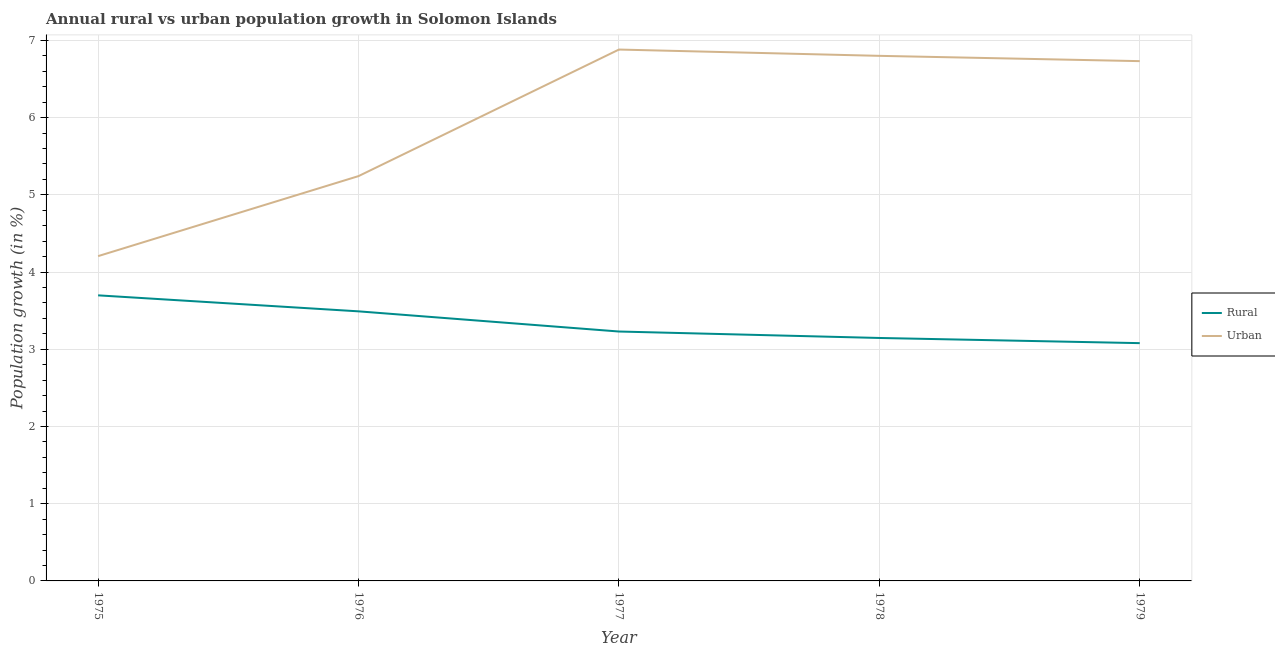How many different coloured lines are there?
Ensure brevity in your answer.  2. What is the urban population growth in 1977?
Offer a very short reply. 6.88. Across all years, what is the maximum rural population growth?
Your response must be concise. 3.7. Across all years, what is the minimum urban population growth?
Your response must be concise. 4.21. In which year was the rural population growth minimum?
Provide a short and direct response. 1979. What is the total urban population growth in the graph?
Provide a short and direct response. 29.86. What is the difference between the rural population growth in 1976 and that in 1977?
Provide a succinct answer. 0.26. What is the difference between the rural population growth in 1979 and the urban population growth in 1975?
Provide a succinct answer. -1.13. What is the average urban population growth per year?
Provide a succinct answer. 5.97. In the year 1979, what is the difference between the urban population growth and rural population growth?
Keep it short and to the point. 3.65. What is the ratio of the urban population growth in 1975 to that in 1979?
Ensure brevity in your answer.  0.62. Is the difference between the urban population growth in 1975 and 1977 greater than the difference between the rural population growth in 1975 and 1977?
Give a very brief answer. No. What is the difference between the highest and the second highest urban population growth?
Provide a short and direct response. 0.08. What is the difference between the highest and the lowest urban population growth?
Provide a short and direct response. 2.67. Is the sum of the rural population growth in 1976 and 1978 greater than the maximum urban population growth across all years?
Keep it short and to the point. No. Does the urban population growth monotonically increase over the years?
Provide a succinct answer. No. How many years are there in the graph?
Make the answer very short. 5. What is the difference between two consecutive major ticks on the Y-axis?
Provide a short and direct response. 1. Where does the legend appear in the graph?
Ensure brevity in your answer.  Center right. How are the legend labels stacked?
Ensure brevity in your answer.  Vertical. What is the title of the graph?
Offer a very short reply. Annual rural vs urban population growth in Solomon Islands. What is the label or title of the X-axis?
Give a very brief answer. Year. What is the label or title of the Y-axis?
Offer a very short reply. Population growth (in %). What is the Population growth (in %) of Rural in 1975?
Your response must be concise. 3.7. What is the Population growth (in %) in Urban  in 1975?
Offer a terse response. 4.21. What is the Population growth (in %) in Rural in 1976?
Your answer should be very brief. 3.49. What is the Population growth (in %) in Urban  in 1976?
Offer a very short reply. 5.24. What is the Population growth (in %) of Rural in 1977?
Make the answer very short. 3.23. What is the Population growth (in %) in Urban  in 1977?
Provide a short and direct response. 6.88. What is the Population growth (in %) in Rural in 1978?
Your answer should be very brief. 3.15. What is the Population growth (in %) in Urban  in 1978?
Provide a succinct answer. 6.8. What is the Population growth (in %) of Rural in 1979?
Make the answer very short. 3.08. What is the Population growth (in %) of Urban  in 1979?
Provide a short and direct response. 6.73. Across all years, what is the maximum Population growth (in %) of Rural?
Make the answer very short. 3.7. Across all years, what is the maximum Population growth (in %) in Urban ?
Provide a short and direct response. 6.88. Across all years, what is the minimum Population growth (in %) of Rural?
Make the answer very short. 3.08. Across all years, what is the minimum Population growth (in %) in Urban ?
Your answer should be compact. 4.21. What is the total Population growth (in %) of Rural in the graph?
Give a very brief answer. 16.64. What is the total Population growth (in %) in Urban  in the graph?
Make the answer very short. 29.86. What is the difference between the Population growth (in %) of Rural in 1975 and that in 1976?
Provide a short and direct response. 0.21. What is the difference between the Population growth (in %) in Urban  in 1975 and that in 1976?
Make the answer very short. -1.04. What is the difference between the Population growth (in %) of Rural in 1975 and that in 1977?
Keep it short and to the point. 0.47. What is the difference between the Population growth (in %) in Urban  in 1975 and that in 1977?
Offer a terse response. -2.67. What is the difference between the Population growth (in %) of Rural in 1975 and that in 1978?
Provide a succinct answer. 0.55. What is the difference between the Population growth (in %) of Urban  in 1975 and that in 1978?
Keep it short and to the point. -2.59. What is the difference between the Population growth (in %) in Rural in 1975 and that in 1979?
Your response must be concise. 0.62. What is the difference between the Population growth (in %) of Urban  in 1975 and that in 1979?
Your answer should be very brief. -2.52. What is the difference between the Population growth (in %) in Rural in 1976 and that in 1977?
Make the answer very short. 0.26. What is the difference between the Population growth (in %) of Urban  in 1976 and that in 1977?
Your answer should be compact. -1.64. What is the difference between the Population growth (in %) in Rural in 1976 and that in 1978?
Keep it short and to the point. 0.34. What is the difference between the Population growth (in %) of Urban  in 1976 and that in 1978?
Give a very brief answer. -1.56. What is the difference between the Population growth (in %) of Rural in 1976 and that in 1979?
Ensure brevity in your answer.  0.41. What is the difference between the Population growth (in %) in Urban  in 1976 and that in 1979?
Your answer should be compact. -1.49. What is the difference between the Population growth (in %) of Rural in 1977 and that in 1978?
Make the answer very short. 0.08. What is the difference between the Population growth (in %) in Urban  in 1977 and that in 1978?
Ensure brevity in your answer.  0.08. What is the difference between the Population growth (in %) of Rural in 1977 and that in 1979?
Offer a terse response. 0.15. What is the difference between the Population growth (in %) in Rural in 1978 and that in 1979?
Offer a terse response. 0.07. What is the difference between the Population growth (in %) in Urban  in 1978 and that in 1979?
Provide a succinct answer. 0.07. What is the difference between the Population growth (in %) in Rural in 1975 and the Population growth (in %) in Urban  in 1976?
Offer a terse response. -1.54. What is the difference between the Population growth (in %) in Rural in 1975 and the Population growth (in %) in Urban  in 1977?
Keep it short and to the point. -3.18. What is the difference between the Population growth (in %) in Rural in 1975 and the Population growth (in %) in Urban  in 1978?
Your answer should be compact. -3.1. What is the difference between the Population growth (in %) in Rural in 1975 and the Population growth (in %) in Urban  in 1979?
Offer a very short reply. -3.03. What is the difference between the Population growth (in %) in Rural in 1976 and the Population growth (in %) in Urban  in 1977?
Your answer should be very brief. -3.39. What is the difference between the Population growth (in %) of Rural in 1976 and the Population growth (in %) of Urban  in 1978?
Your answer should be very brief. -3.31. What is the difference between the Population growth (in %) in Rural in 1976 and the Population growth (in %) in Urban  in 1979?
Make the answer very short. -3.24. What is the difference between the Population growth (in %) in Rural in 1977 and the Population growth (in %) in Urban  in 1978?
Offer a very short reply. -3.57. What is the difference between the Population growth (in %) in Rural in 1977 and the Population growth (in %) in Urban  in 1979?
Keep it short and to the point. -3.5. What is the difference between the Population growth (in %) of Rural in 1978 and the Population growth (in %) of Urban  in 1979?
Provide a short and direct response. -3.58. What is the average Population growth (in %) of Rural per year?
Make the answer very short. 3.33. What is the average Population growth (in %) of Urban  per year?
Offer a very short reply. 5.97. In the year 1975, what is the difference between the Population growth (in %) in Rural and Population growth (in %) in Urban ?
Provide a short and direct response. -0.51. In the year 1976, what is the difference between the Population growth (in %) in Rural and Population growth (in %) in Urban ?
Your response must be concise. -1.75. In the year 1977, what is the difference between the Population growth (in %) of Rural and Population growth (in %) of Urban ?
Your answer should be very brief. -3.65. In the year 1978, what is the difference between the Population growth (in %) of Rural and Population growth (in %) of Urban ?
Your answer should be compact. -3.65. In the year 1979, what is the difference between the Population growth (in %) in Rural and Population growth (in %) in Urban ?
Offer a very short reply. -3.65. What is the ratio of the Population growth (in %) in Rural in 1975 to that in 1976?
Your answer should be very brief. 1.06. What is the ratio of the Population growth (in %) of Urban  in 1975 to that in 1976?
Your response must be concise. 0.8. What is the ratio of the Population growth (in %) in Rural in 1975 to that in 1977?
Provide a succinct answer. 1.15. What is the ratio of the Population growth (in %) in Urban  in 1975 to that in 1977?
Give a very brief answer. 0.61. What is the ratio of the Population growth (in %) of Rural in 1975 to that in 1978?
Provide a succinct answer. 1.18. What is the ratio of the Population growth (in %) of Urban  in 1975 to that in 1978?
Ensure brevity in your answer.  0.62. What is the ratio of the Population growth (in %) in Rural in 1975 to that in 1979?
Your response must be concise. 1.2. What is the ratio of the Population growth (in %) of Urban  in 1975 to that in 1979?
Provide a short and direct response. 0.62. What is the ratio of the Population growth (in %) in Rural in 1976 to that in 1977?
Your response must be concise. 1.08. What is the ratio of the Population growth (in %) of Urban  in 1976 to that in 1977?
Provide a succinct answer. 0.76. What is the ratio of the Population growth (in %) of Rural in 1976 to that in 1978?
Keep it short and to the point. 1.11. What is the ratio of the Population growth (in %) of Urban  in 1976 to that in 1978?
Give a very brief answer. 0.77. What is the ratio of the Population growth (in %) of Rural in 1976 to that in 1979?
Offer a terse response. 1.13. What is the ratio of the Population growth (in %) in Urban  in 1976 to that in 1979?
Provide a succinct answer. 0.78. What is the ratio of the Population growth (in %) in Rural in 1977 to that in 1978?
Give a very brief answer. 1.03. What is the ratio of the Population growth (in %) of Urban  in 1977 to that in 1978?
Make the answer very short. 1.01. What is the ratio of the Population growth (in %) of Rural in 1977 to that in 1979?
Your answer should be compact. 1.05. What is the ratio of the Population growth (in %) of Urban  in 1977 to that in 1979?
Your response must be concise. 1.02. What is the ratio of the Population growth (in %) in Rural in 1978 to that in 1979?
Keep it short and to the point. 1.02. What is the ratio of the Population growth (in %) in Urban  in 1978 to that in 1979?
Ensure brevity in your answer.  1.01. What is the difference between the highest and the second highest Population growth (in %) of Rural?
Make the answer very short. 0.21. What is the difference between the highest and the second highest Population growth (in %) of Urban ?
Provide a short and direct response. 0.08. What is the difference between the highest and the lowest Population growth (in %) of Rural?
Your answer should be very brief. 0.62. What is the difference between the highest and the lowest Population growth (in %) of Urban ?
Give a very brief answer. 2.67. 